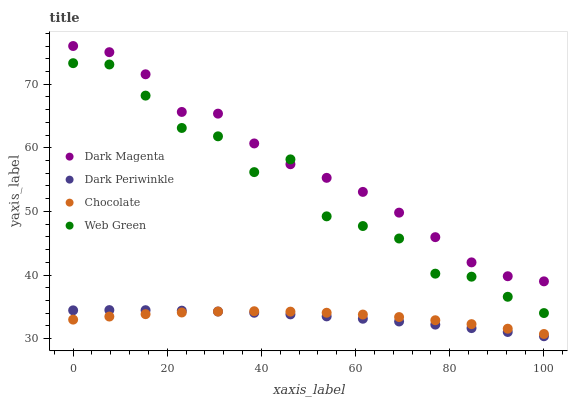Does Dark Periwinkle have the minimum area under the curve?
Answer yes or no. Yes. Does Dark Magenta have the maximum area under the curve?
Answer yes or no. Yes. Does Web Green have the minimum area under the curve?
Answer yes or no. No. Does Web Green have the maximum area under the curve?
Answer yes or no. No. Is Dark Periwinkle the smoothest?
Answer yes or no. Yes. Is Web Green the roughest?
Answer yes or no. Yes. Is Dark Magenta the smoothest?
Answer yes or no. No. Is Dark Magenta the roughest?
Answer yes or no. No. Does Dark Periwinkle have the lowest value?
Answer yes or no. Yes. Does Web Green have the lowest value?
Answer yes or no. No. Does Dark Magenta have the highest value?
Answer yes or no. Yes. Does Web Green have the highest value?
Answer yes or no. No. Is Chocolate less than Web Green?
Answer yes or no. Yes. Is Dark Magenta greater than Chocolate?
Answer yes or no. Yes. Does Chocolate intersect Dark Periwinkle?
Answer yes or no. Yes. Is Chocolate less than Dark Periwinkle?
Answer yes or no. No. Is Chocolate greater than Dark Periwinkle?
Answer yes or no. No. Does Chocolate intersect Web Green?
Answer yes or no. No. 